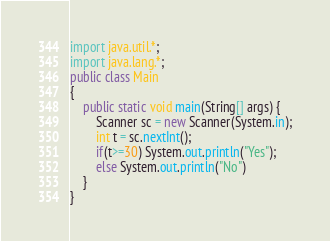Convert code to text. <code><loc_0><loc_0><loc_500><loc_500><_Java_>import java.util.*;
import java.lang.*;
public class Main
{
	public static void main(String[] args) {
		Scanner sc = new Scanner(System.in);
		int t = sc.nextInt();
		if(t>=30) System.out.println("Yes");
        else System.out.println("No")
	}
}
</code> 